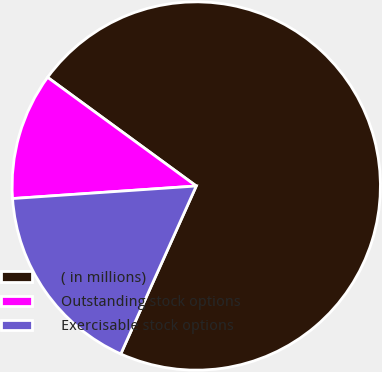<chart> <loc_0><loc_0><loc_500><loc_500><pie_chart><fcel>( in millions)<fcel>Outstanding stock options<fcel>Exercisable stock options<nl><fcel>71.68%<fcel>11.13%<fcel>17.19%<nl></chart> 